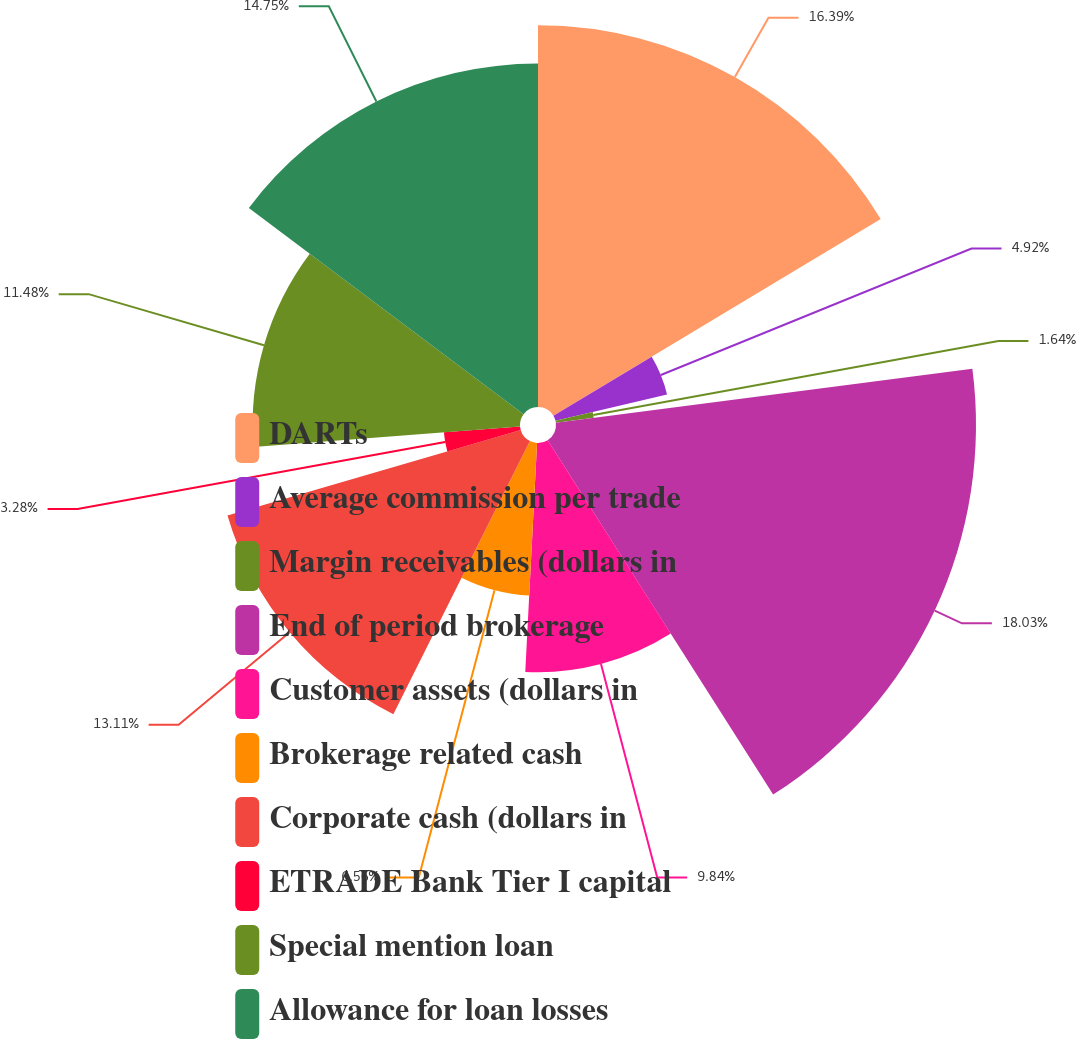Convert chart to OTSL. <chart><loc_0><loc_0><loc_500><loc_500><pie_chart><fcel>DARTs<fcel>Average commission per trade<fcel>Margin receivables (dollars in<fcel>End of period brokerage<fcel>Customer assets (dollars in<fcel>Brokerage related cash<fcel>Corporate cash (dollars in<fcel>ETRADE Bank Tier I capital<fcel>Special mention loan<fcel>Allowance for loan losses<nl><fcel>16.39%<fcel>4.92%<fcel>1.64%<fcel>18.03%<fcel>9.84%<fcel>6.56%<fcel>13.11%<fcel>3.28%<fcel>11.48%<fcel>14.75%<nl></chart> 